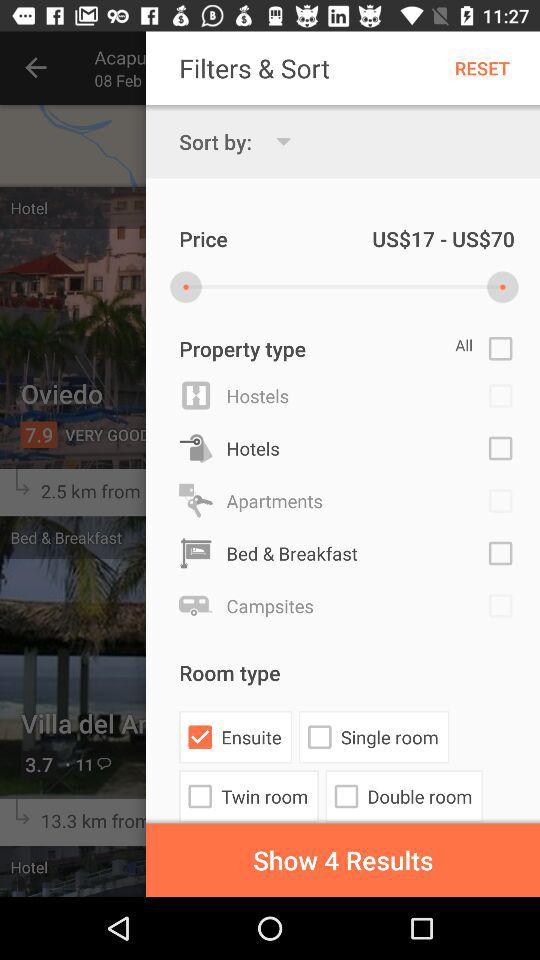What is the price range of the hotels?
Answer the question using a single word or phrase. US$17 - US$70 